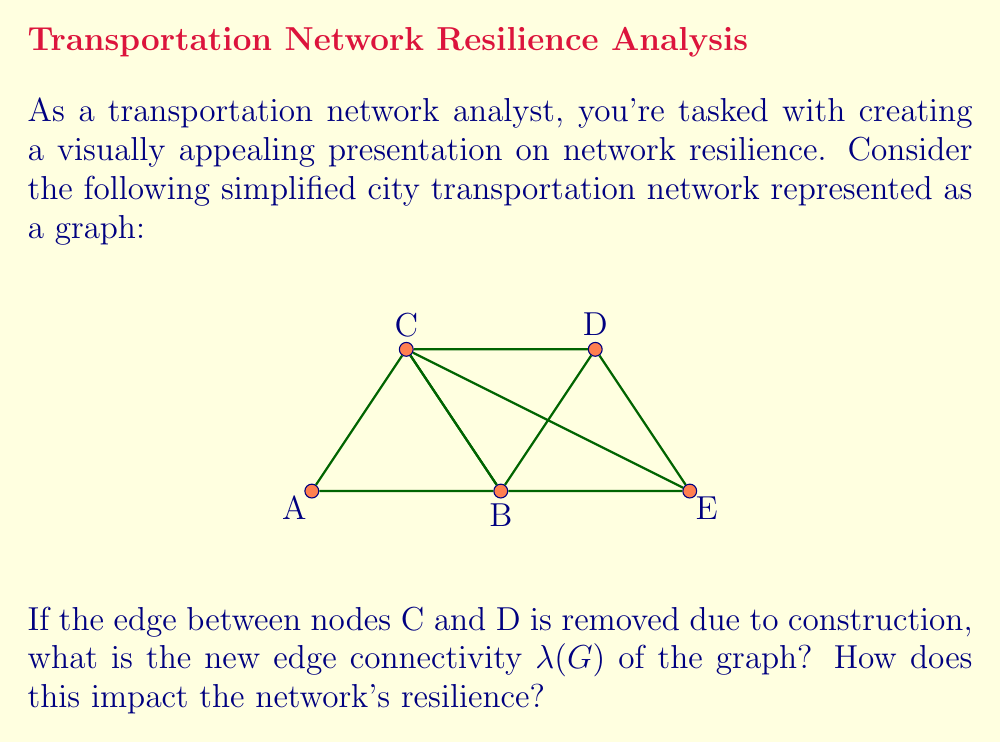Show me your answer to this math problem. To solve this problem, we'll follow these steps:

1) First, recall that the edge connectivity $\lambda(G)$ is the minimum number of edges that need to be removed to disconnect the graph.

2) In the original graph, we have:
   - 5 nodes (A, B, C, D, E)
   - 8 edges (AB, BC, CD, DE, BE, AC, CE, BD)

3) After removing edge CD, we have 7 edges remaining.

4) To find $\lambda(G)$, we need to determine the minimum cut set:

   - Removing AB and BE disconnects A from the rest: 2 edges
   - Removing AC and CE disconnects A from the rest: 2 edges
   - Removing BC and BD disconnects B from the rest: 2 edges
   - Removing DE and BE disconnects E from the rest: 2 edges

5) The minimum number of edges to disconnect the graph is 2, so $\lambda(G) = 2$.

6) Impact on resilience:
   - The original graph likely had $\lambda(G) = 3$ (removing C would require cutting 3 edges).
   - Reducing $\lambda(G)$ from 3 to 2 means the network is more vulnerable to disconnection.
   - However, $\lambda(G) = 2$ still indicates some level of redundancy, as no single edge failure can disconnect the network.

This analysis shows that while the construction has reduced the network's resilience, it still maintains a degree of robustness against single point failures.
Answer: $\lambda(G) = 2$; Reduced resilience but still robust against single failures. 